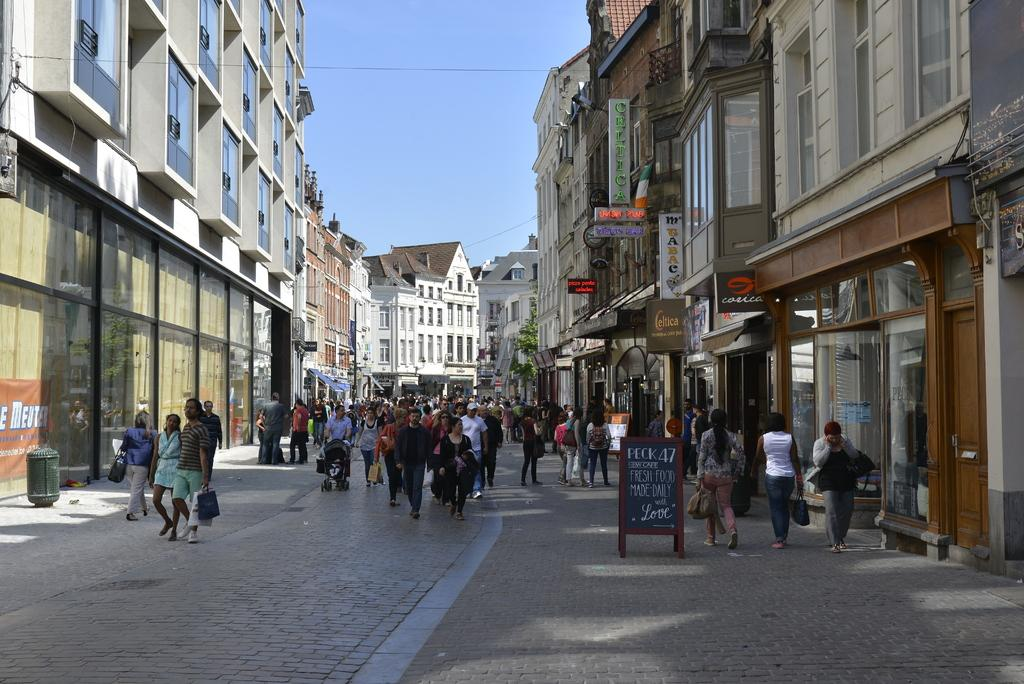What is happening on the road in the image? There are persons on the road in the image. What type of establishments can be seen in the image? There are stores in the image. What kind of structures are present in the image? There are buildings in the image. Can you describe any architectural features in the image? There are windows visible in the image. What might be used for providing information to people in the image? Information boards are present in the image. What type of transportation is visible in the image? There are prams in the image. What items might people be carrying in the image? Bags are visible in the image. What type of natural elements can be seen in the image? Trees are present in the image. What part of the natural environment is visible in the image? The sky is visible in the image. What type of approval is required for the carpenter to work on the buildings in the image? There is no carpenter present in the image, and therefore no such approval is required. How many fifths are visible in the image? The term "fifth" does not apply to any elements in the image, as it is a mathematical or musical concept rather than a visual one. 